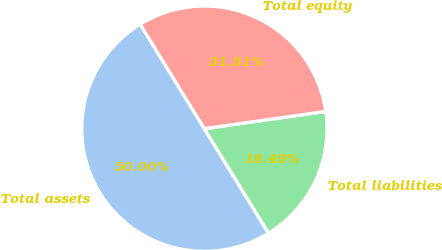Convert chart to OTSL. <chart><loc_0><loc_0><loc_500><loc_500><pie_chart><fcel>Total assets<fcel>Total liabilities<fcel>Total equity<nl><fcel>50.0%<fcel>18.49%<fcel>31.51%<nl></chart> 